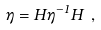Convert formula to latex. <formula><loc_0><loc_0><loc_500><loc_500>\eta = H \eta ^ { - 1 } H \ ,</formula> 